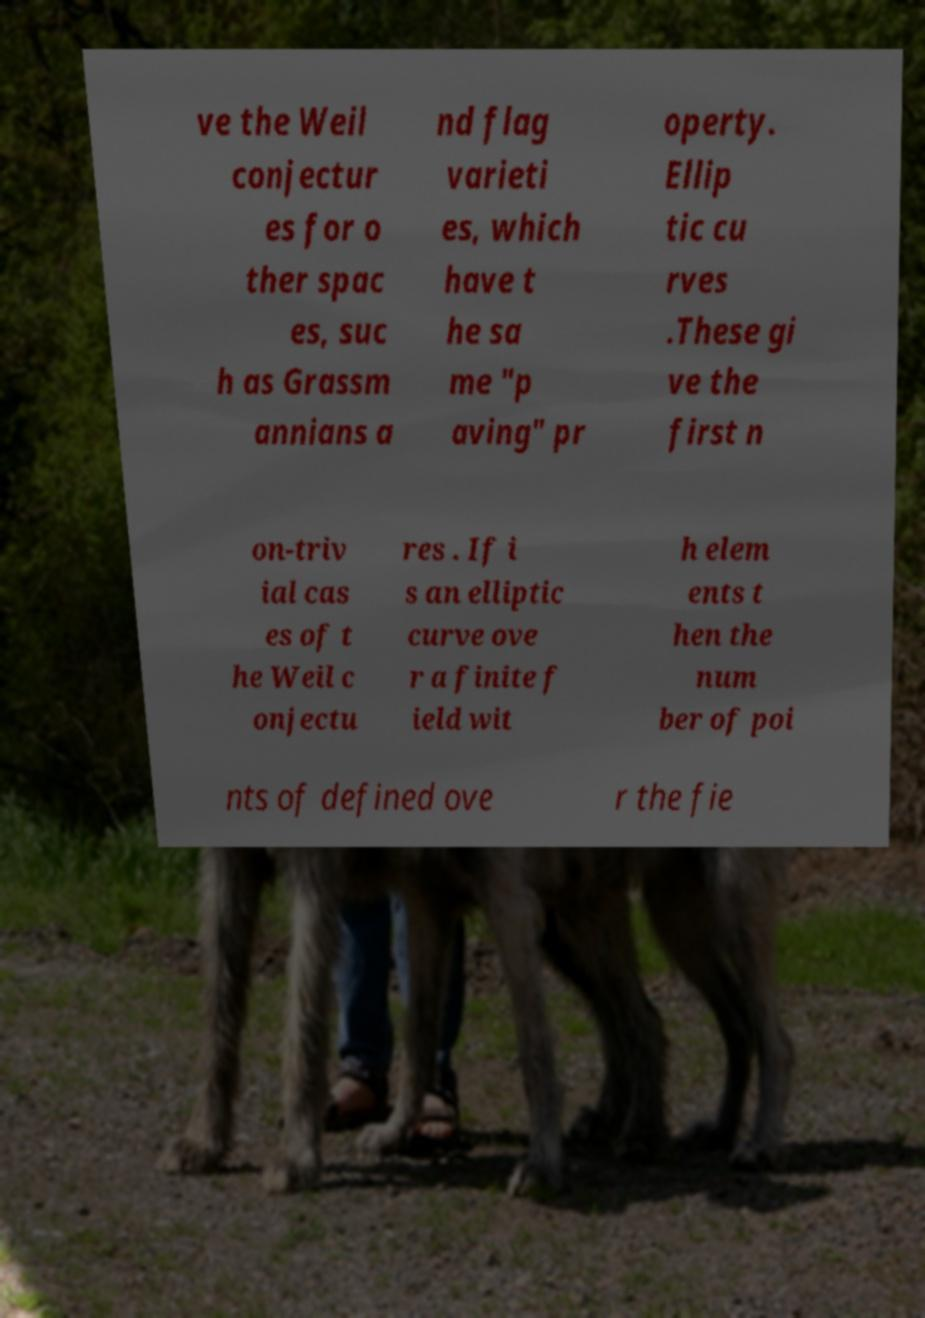Can you read and provide the text displayed in the image?This photo seems to have some interesting text. Can you extract and type it out for me? ve the Weil conjectur es for o ther spac es, suc h as Grassm annians a nd flag varieti es, which have t he sa me "p aving" pr operty. Ellip tic cu rves .These gi ve the first n on-triv ial cas es of t he Weil c onjectu res . If i s an elliptic curve ove r a finite f ield wit h elem ents t hen the num ber of poi nts of defined ove r the fie 